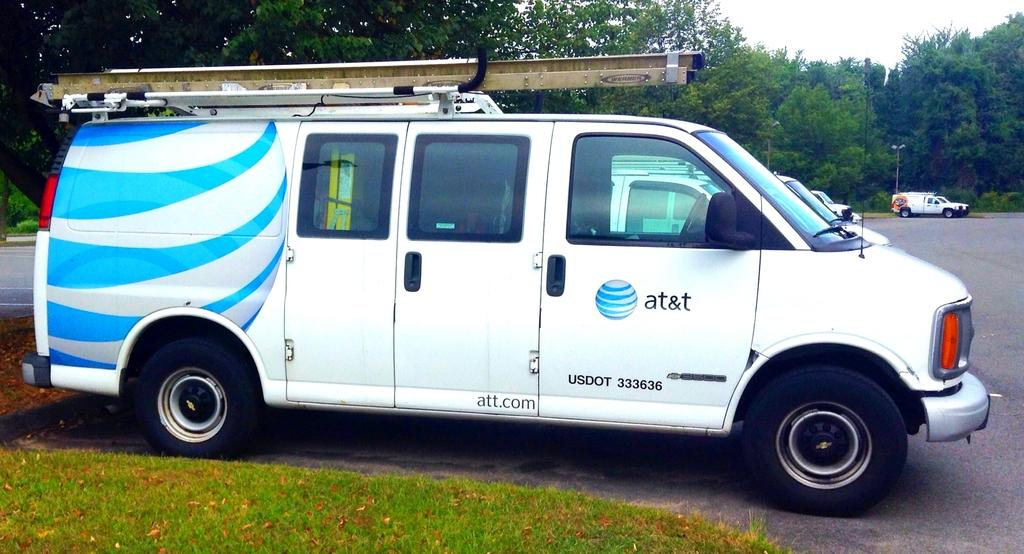<image>
Relay a brief, clear account of the picture shown. An AT&T van has a USDOT code at the bottom of the door. 